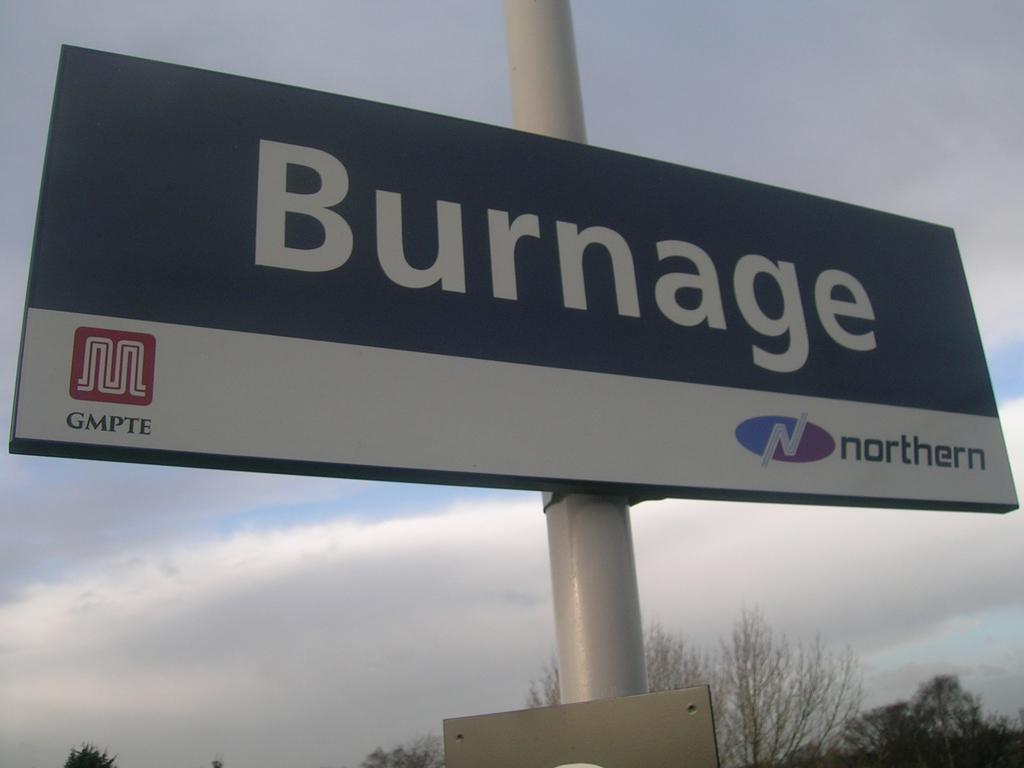<image>
Render a clear and concise summary of the photo. the word burnage that is on a sign 